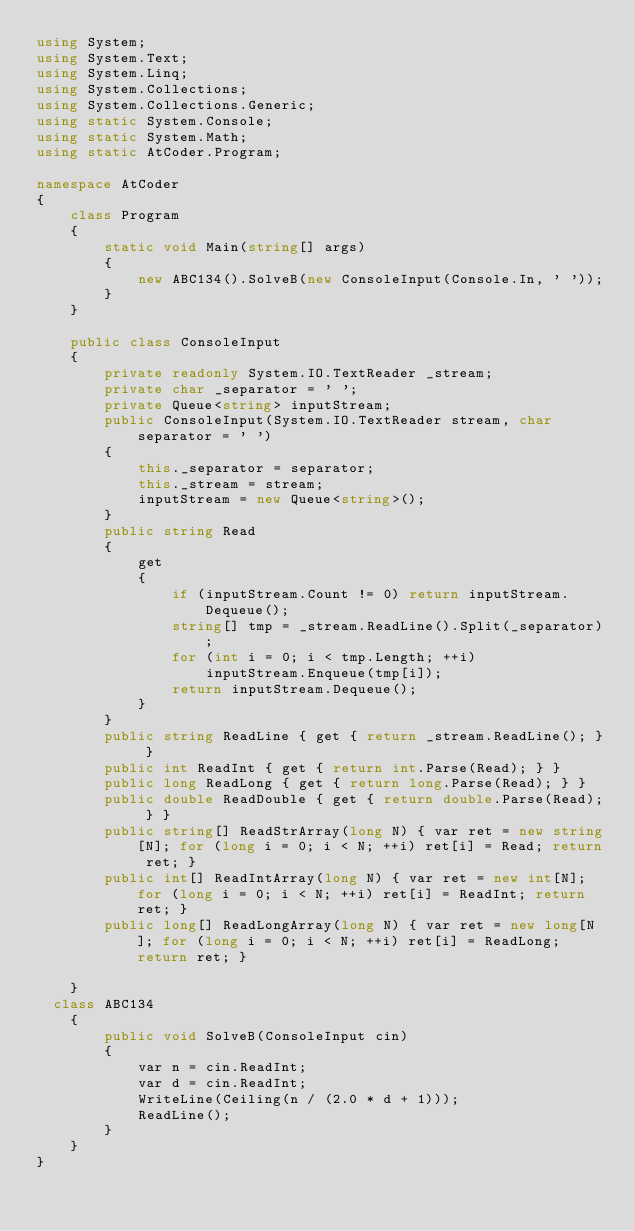Convert code to text. <code><loc_0><loc_0><loc_500><loc_500><_C#_>using System;
using System.Text;
using System.Linq;
using System.Collections;
using System.Collections.Generic;
using static System.Console;
using static System.Math;
using static AtCoder.Program;
 
namespace AtCoder
{
    class Program
    {
        static void Main(string[] args)
        {
            new ABC134().SolveB(new ConsoleInput(Console.In, ' '));
        }
    }
 
    public class ConsoleInput
    {
        private readonly System.IO.TextReader _stream;
        private char _separator = ' ';
        private Queue<string> inputStream;
        public ConsoleInput(System.IO.TextReader stream, char separator = ' ')
        {
            this._separator = separator;
            this._stream = stream;
            inputStream = new Queue<string>();
        }
        public string Read
        {
            get
            {
                if (inputStream.Count != 0) return inputStream.Dequeue();
                string[] tmp = _stream.ReadLine().Split(_separator);
                for (int i = 0; i < tmp.Length; ++i)
                    inputStream.Enqueue(tmp[i]);
                return inputStream.Dequeue();
            }
        }
        public string ReadLine { get { return _stream.ReadLine(); } }
        public int ReadInt { get { return int.Parse(Read); } }
        public long ReadLong { get { return long.Parse(Read); } }
        public double ReadDouble { get { return double.Parse(Read); } }
        public string[] ReadStrArray(long N) { var ret = new string[N]; for (long i = 0; i < N; ++i) ret[i] = Read; return ret; }
        public int[] ReadIntArray(long N) { var ret = new int[N]; for (long i = 0; i < N; ++i) ret[i] = ReadInt; return ret; }
        public long[] ReadLongArray(long N) { var ret = new long[N]; for (long i = 0; i < N; ++i) ret[i] = ReadLong; return ret; }
 
    }
  class ABC134
    {
        public void SolveB(ConsoleInput cin)
        {
            var n = cin.ReadInt;
            var d = cin.ReadInt;
            WriteLine(Ceiling(n / (2.0 * d + 1)));
            ReadLine();
        }
    }
}</code> 